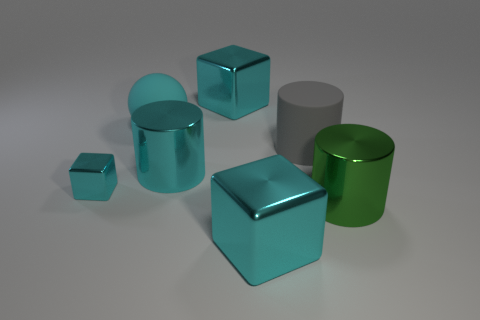Are there any repeating patterns or symmetry in the arrangement of the objects? There is a subtle symmetry in terms of shape repetition. There are two cubic objects and two cylindrical objects, one large and one small of each kind, which creates a pattern of repetition in the object types. However, their arrangement on the surface appears random without any clear line of symmetry or organized pattern. What could be a possible application for these objects if they were real? If these objects were real, they could serve a variety of purposes. The cylinders might be used as containers or holders, while the cubes could be weights or building blocks. Given their different sizes, they could also be parts of a modular system, where the smaller objects fit into or interact with the larger ones, possibly in a storage or construction context. 